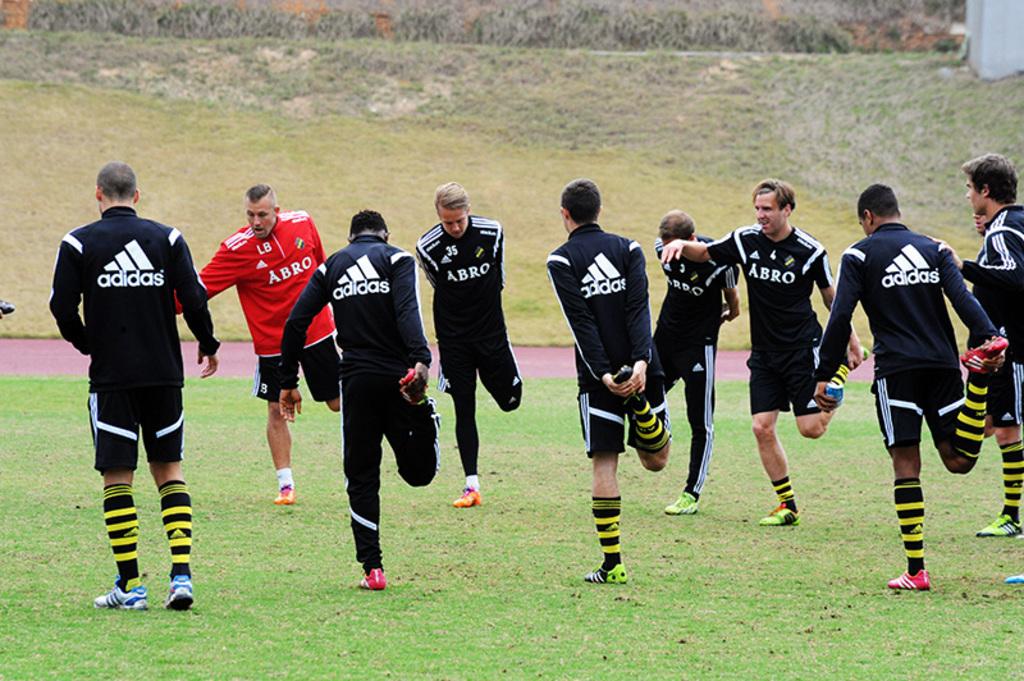What brand of jerseys are they all wearing?
Give a very brief answer. Adidas. What is on the front of the shirts?
Offer a very short reply. Abro. 